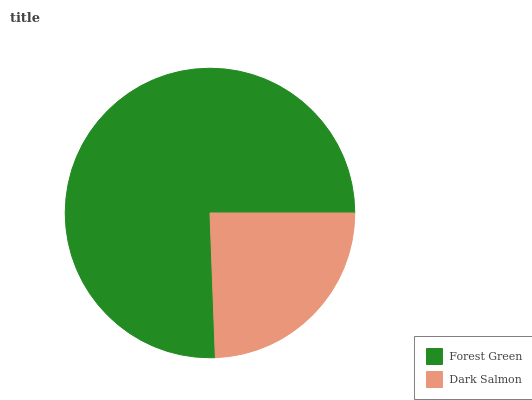Is Dark Salmon the minimum?
Answer yes or no. Yes. Is Forest Green the maximum?
Answer yes or no. Yes. Is Dark Salmon the maximum?
Answer yes or no. No. Is Forest Green greater than Dark Salmon?
Answer yes or no. Yes. Is Dark Salmon less than Forest Green?
Answer yes or no. Yes. Is Dark Salmon greater than Forest Green?
Answer yes or no. No. Is Forest Green less than Dark Salmon?
Answer yes or no. No. Is Forest Green the high median?
Answer yes or no. Yes. Is Dark Salmon the low median?
Answer yes or no. Yes. Is Dark Salmon the high median?
Answer yes or no. No. Is Forest Green the low median?
Answer yes or no. No. 